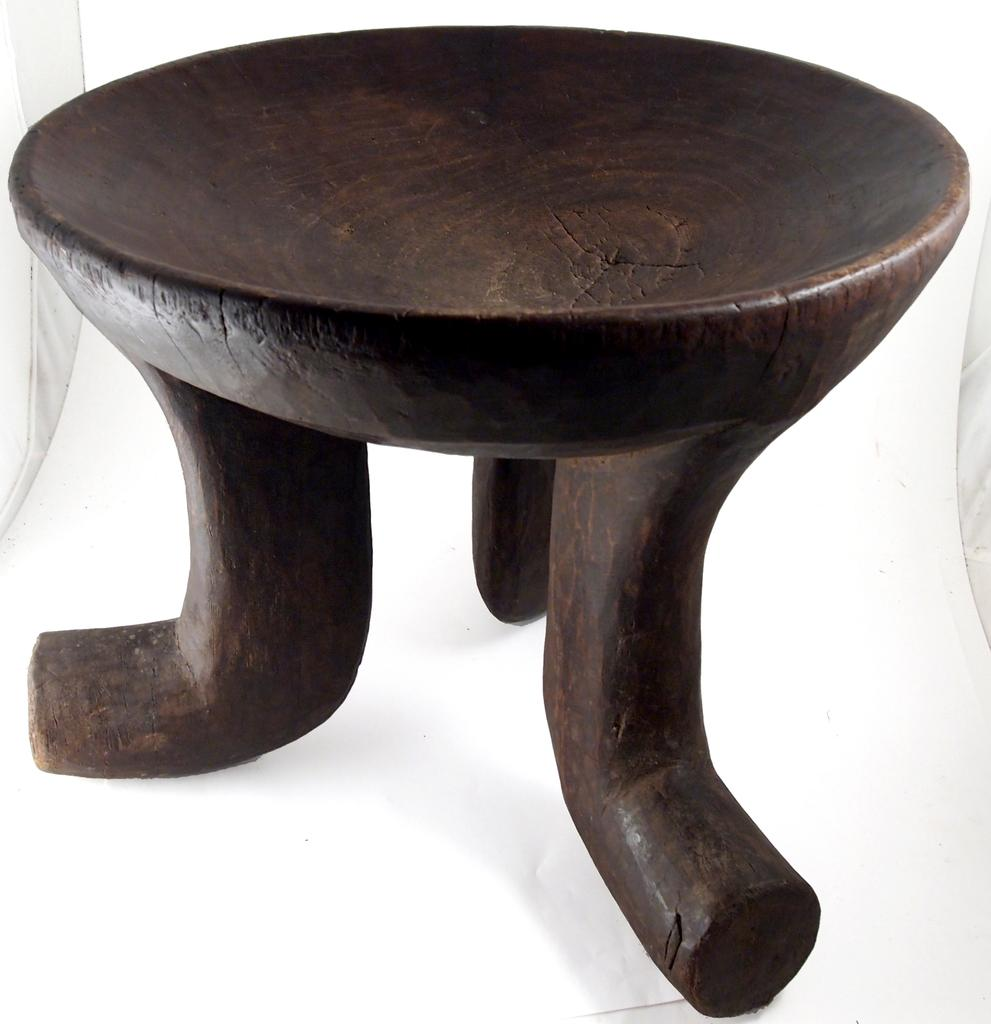What color is the object that is visible in the image? The object is brown. What is the color of the surface on which the brown object is placed? The surface is white. What facial expression can be seen on the brown object in the image? There is no face or facial expression present on the brown object in the image. 